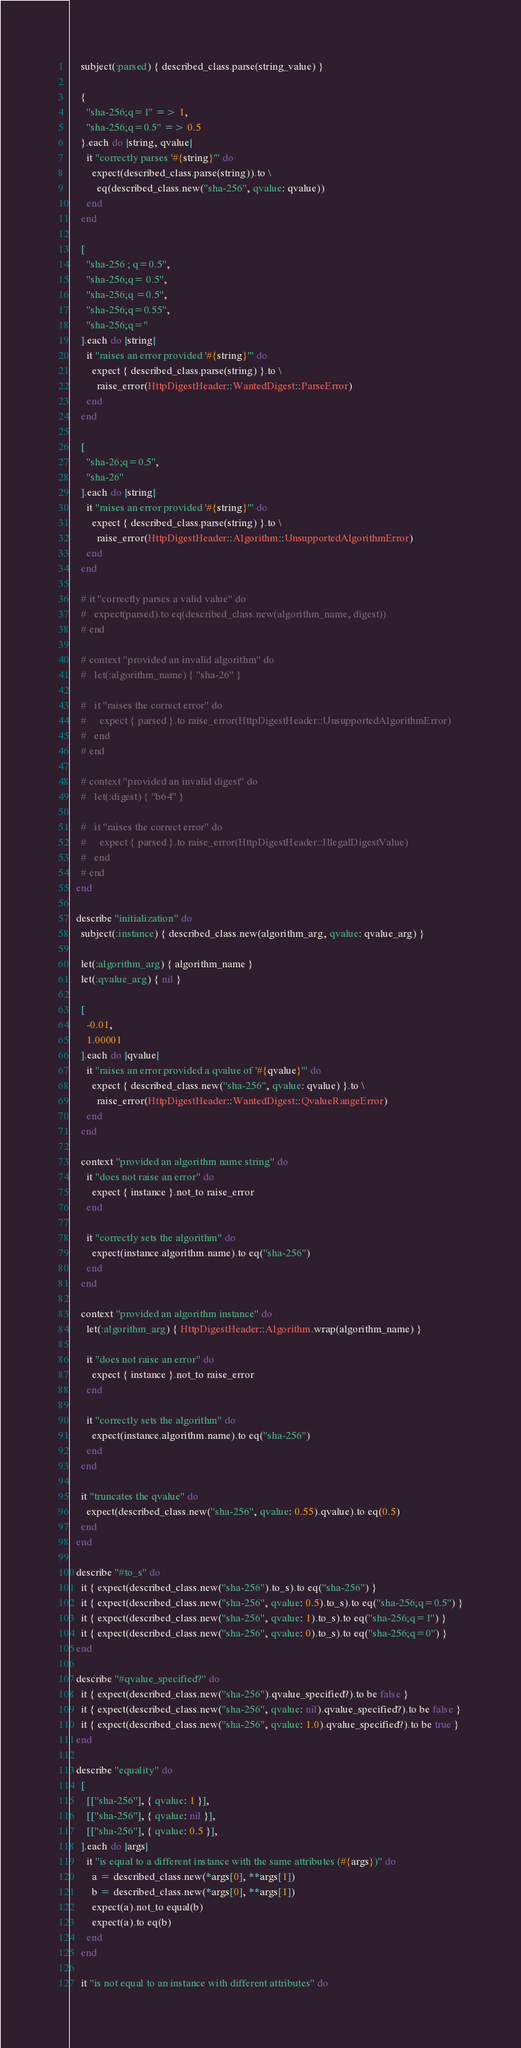<code> <loc_0><loc_0><loc_500><loc_500><_Ruby_>    subject(:parsed) { described_class.parse(string_value) }

    {
      "sha-256;q=1" => 1,
      "sha-256;q=0.5" => 0.5
    }.each do |string, qvalue|
      it "correctly parses '#{string}'" do
        expect(described_class.parse(string)).to \
          eq(described_class.new("sha-256", qvalue: qvalue))
      end
    end

    [
      "sha-256 ; q=0.5",
      "sha-256;q= 0.5",
      "sha-256;q =0.5",
      "sha-256;q=0.55",
      "sha-256;q="
    ].each do |string|
      it "raises an error provided '#{string}'" do
        expect { described_class.parse(string) }.to \
          raise_error(HttpDigestHeader::WantedDigest::ParseError)
      end
    end

    [
      "sha-26;q=0.5",
      "sha-26"
    ].each do |string|
      it "raises an error provided '#{string}'" do
        expect { described_class.parse(string) }.to \
          raise_error(HttpDigestHeader::Algorithm::UnsupportedAlgorithmError)
      end
    end

    # it "correctly parses a valid value" do
    #   expect(parsed).to eq(described_class.new(algorithm_name, digest))
    # end

    # context "provided an invalid algorithm" do
    #   let(:algorithm_name) { "sha-26" }

    #   it "raises the correct error" do
    #     expect { parsed }.to raise_error(HttpDigestHeader::UnsupportedAlgorithmError)
    #   end
    # end

    # context "provided an invalid digest" do
    #   let(:digest) { "b64" }

    #   it "raises the correct error" do
    #     expect { parsed }.to raise_error(HttpDigestHeader::IllegalDigestValue)
    #   end
    # end
  end

  describe "initialization" do
    subject(:instance) { described_class.new(algorithm_arg, qvalue: qvalue_arg) }

    let(:algorithm_arg) { algorithm_name }
    let(:qvalue_arg) { nil }

    [
      -0.01,
      1.00001
    ].each do |qvalue|
      it "raises an error provided a qvalue of '#{qvalue}'" do
        expect { described_class.new("sha-256", qvalue: qvalue) }.to \
          raise_error(HttpDigestHeader::WantedDigest::QvalueRangeError)
      end
    end

    context "provided an algorithm name string" do
      it "does not raise an error" do
        expect { instance }.not_to raise_error
      end

      it "correctly sets the algorithm" do
        expect(instance.algorithm.name).to eq("sha-256")
      end
    end

    context "provided an algorithm instance" do
      let(:algorithm_arg) { HttpDigestHeader::Algorithm.wrap(algorithm_name) }

      it "does not raise an error" do
        expect { instance }.not_to raise_error
      end

      it "correctly sets the algorithm" do
        expect(instance.algorithm.name).to eq("sha-256")
      end
    end

    it "truncates the qvalue" do
      expect(described_class.new("sha-256", qvalue: 0.55).qvalue).to eq(0.5)
    end
  end

  describe "#to_s" do
    it { expect(described_class.new("sha-256").to_s).to eq("sha-256") }
    it { expect(described_class.new("sha-256", qvalue: 0.5).to_s).to eq("sha-256;q=0.5") }
    it { expect(described_class.new("sha-256", qvalue: 1).to_s).to eq("sha-256;q=1") }
    it { expect(described_class.new("sha-256", qvalue: 0).to_s).to eq("sha-256;q=0") }
  end

  describe "#qvalue_specified?" do
    it { expect(described_class.new("sha-256").qvalue_specified?).to be false }
    it { expect(described_class.new("sha-256", qvalue: nil).qvalue_specified?).to be false }
    it { expect(described_class.new("sha-256", qvalue: 1.0).qvalue_specified?).to be true }
  end

  describe "equality" do
    [
      [["sha-256"], { qvalue: 1 }],
      [["sha-256"], { qvalue: nil }],
      [["sha-256"], { qvalue: 0.5 }],
    ].each do |args|
      it "is equal to a different instance with the same attributes (#{args})" do
        a = described_class.new(*args[0], **args[1])
        b = described_class.new(*args[0], **args[1])
        expect(a).not_to equal(b)
        expect(a).to eq(b)
      end
    end

    it "is not equal to an instance with different attributes" do</code> 